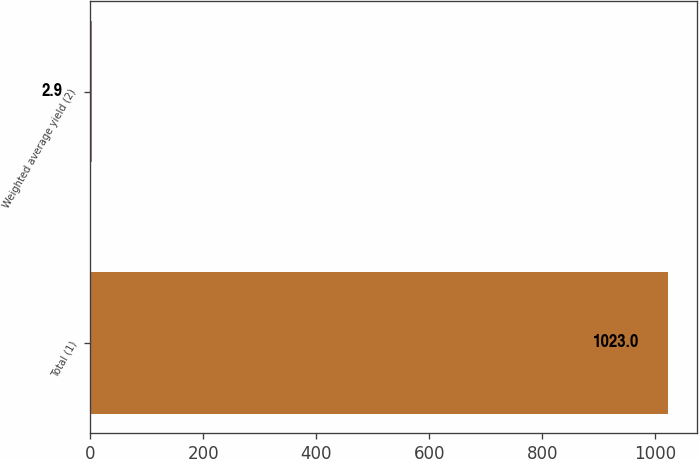Convert chart to OTSL. <chart><loc_0><loc_0><loc_500><loc_500><bar_chart><fcel>Total (1)<fcel>Weighted average yield (2)<nl><fcel>1023<fcel>2.9<nl></chart> 